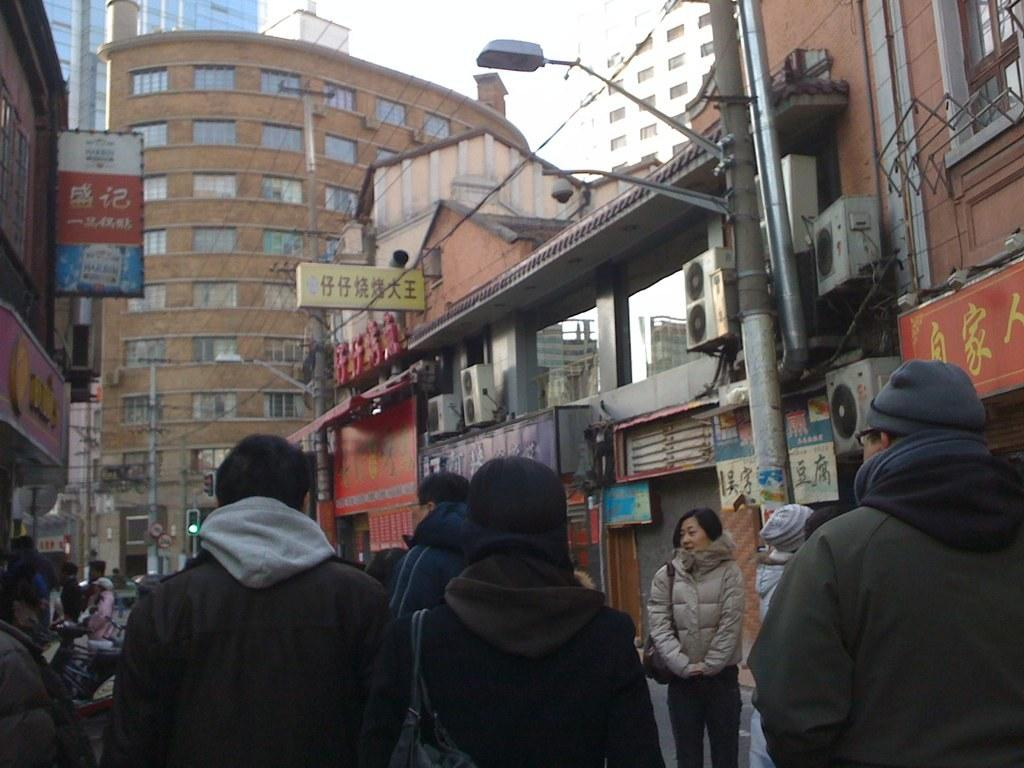What are the people in the image wearing? The people in the image are wearing clothes. What can be seen in front of the buildings in the image? There are street poles in front of the buildings. What is on the building in the image? There is a board on a building. What is visible at the top of the image? The sky is visible at the top of the image. What book is the person reading in the image? There is no book present in the image; the people are wearing clothes and standing near buildings. 